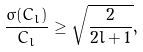<formula> <loc_0><loc_0><loc_500><loc_500>\frac { \sigma ( C _ { l } ) } { C _ { l } } \geq \sqrt { \frac { 2 } { 2 l + 1 } } ,</formula> 